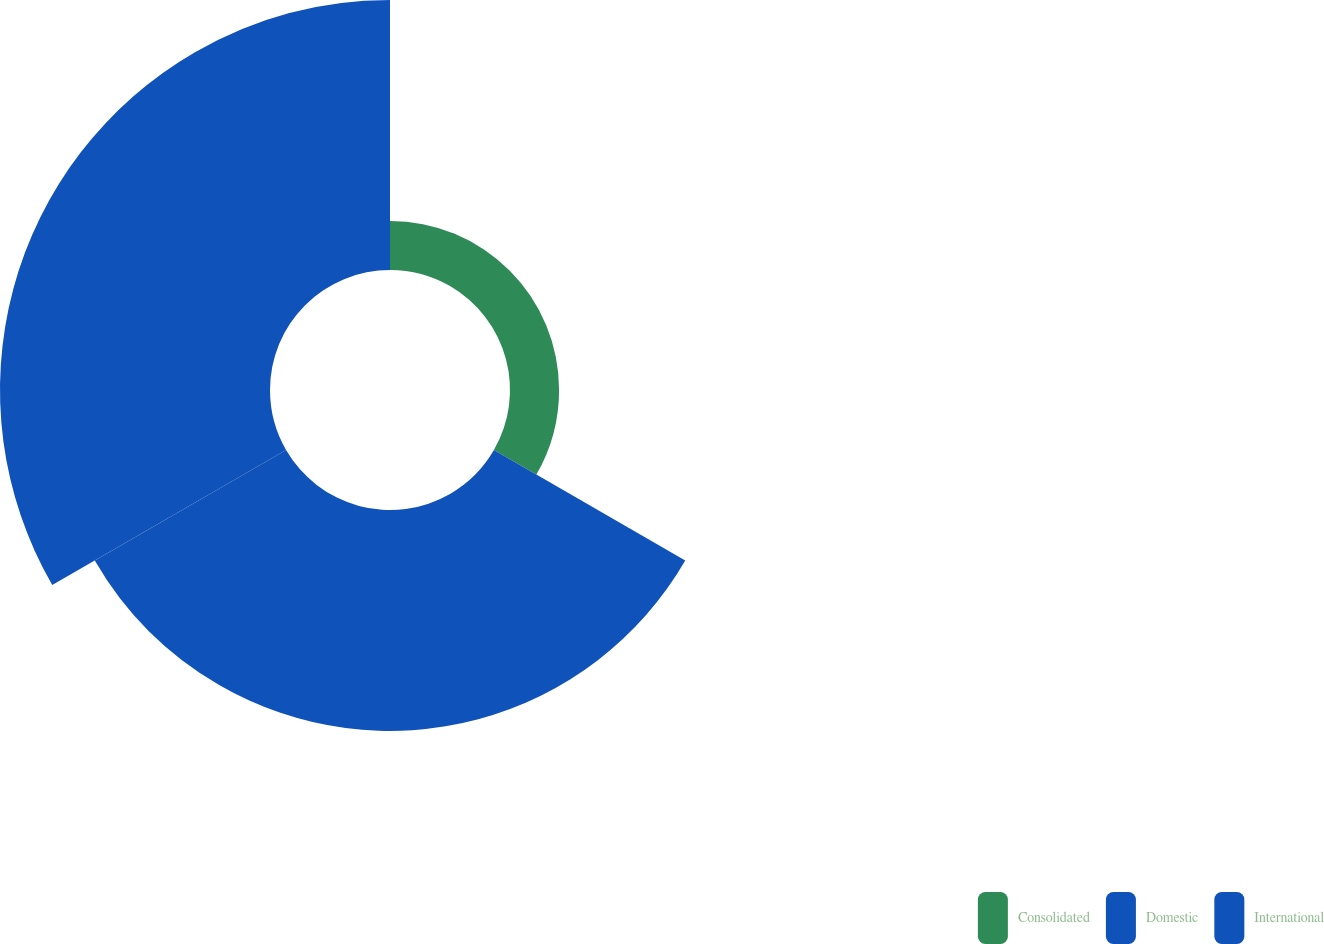Convert chart. <chart><loc_0><loc_0><loc_500><loc_500><pie_chart><fcel>Consolidated<fcel>Domestic<fcel>International<nl><fcel>9.09%<fcel>40.91%<fcel>50.0%<nl></chart> 